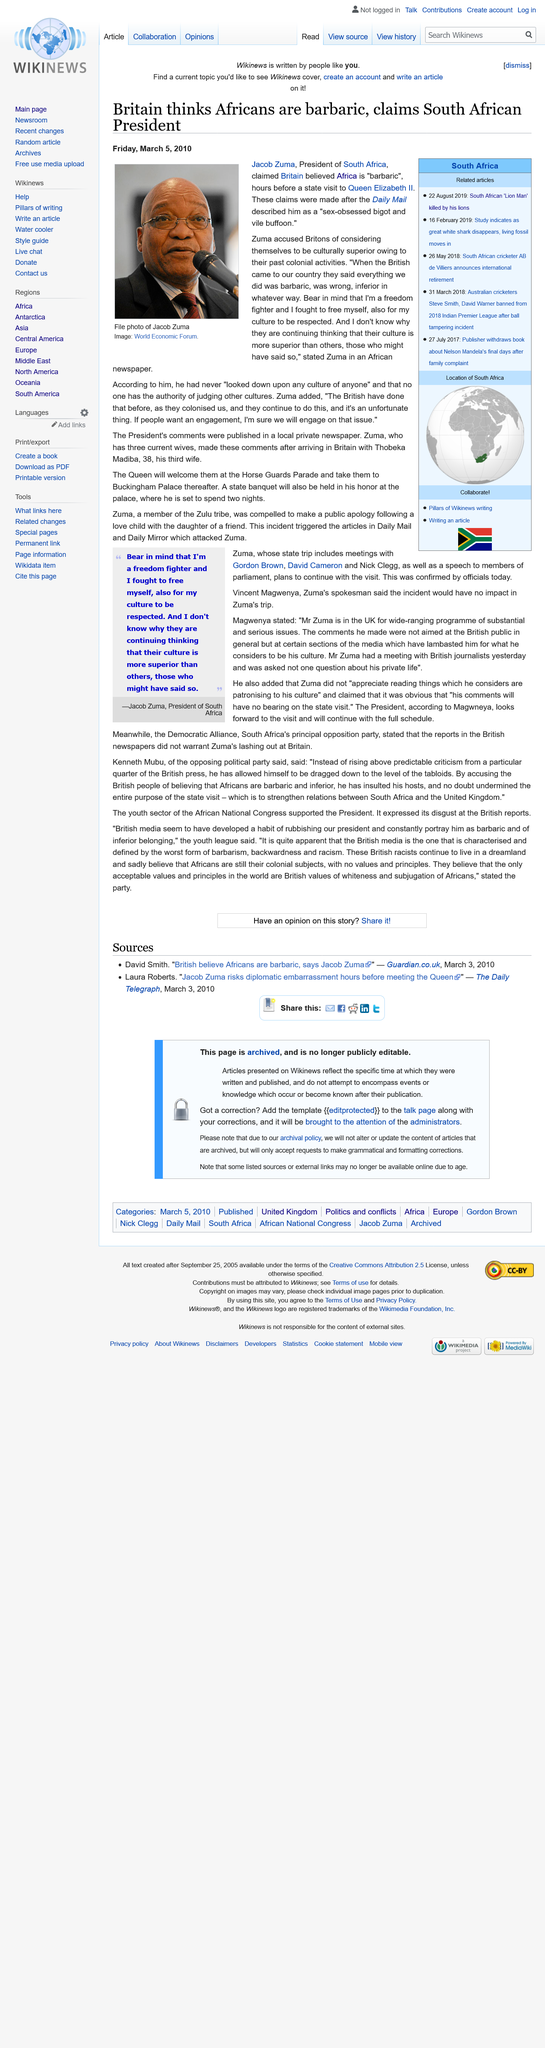List a handful of essential elements in this visual. The President of South Africa was described by Dailymail as being a "sex-obsessed bigot and vile buffoon. On August 22nd, 2019, the "lion man" was killed by his own lions, as stated in the related articles section. The picture shows Jacob Zuma, and the photo features him prominently. 